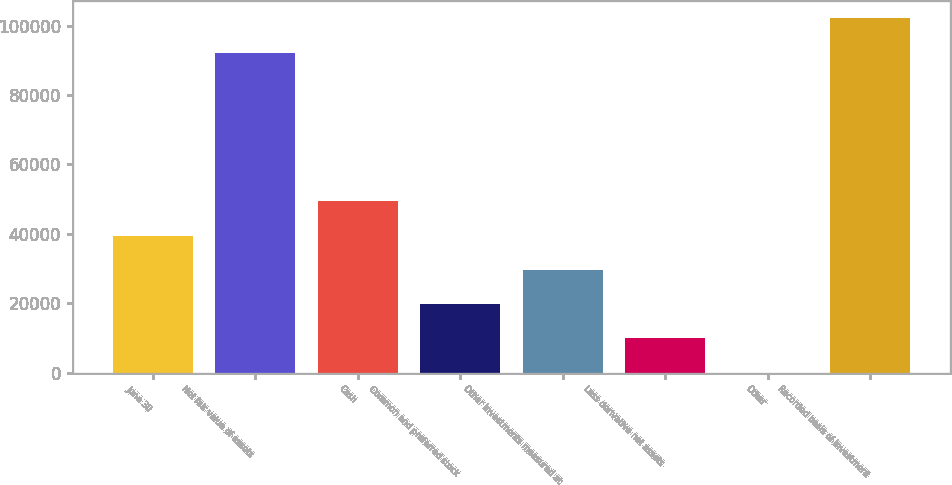Convert chart to OTSL. <chart><loc_0><loc_0><loc_500><loc_500><bar_chart><fcel>June 30<fcel>Net fair value of assets<fcel>Cash<fcel>Common and preferred stock<fcel>Other investments measured at<fcel>Less derivative net assets<fcel>Other<fcel>Recorded basis of investment<nl><fcel>39511.6<fcel>92164<fcel>49388<fcel>19758.8<fcel>29635.2<fcel>9882.4<fcel>6<fcel>102040<nl></chart> 